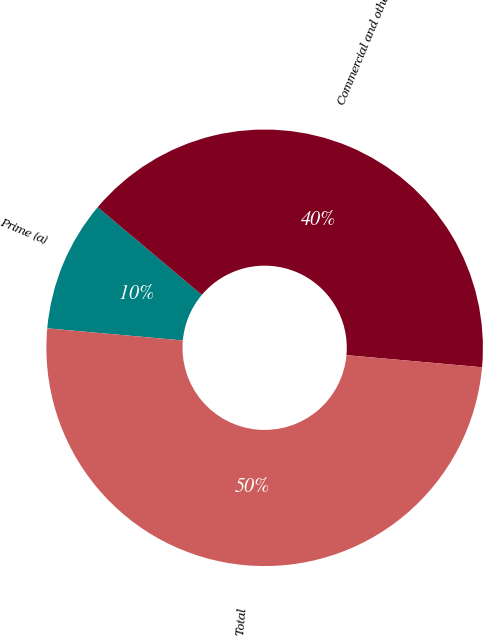<chart> <loc_0><loc_0><loc_500><loc_500><pie_chart><fcel>Prime (a)<fcel>Commercial and other<fcel>Total<nl><fcel>9.72%<fcel>40.28%<fcel>50.0%<nl></chart> 